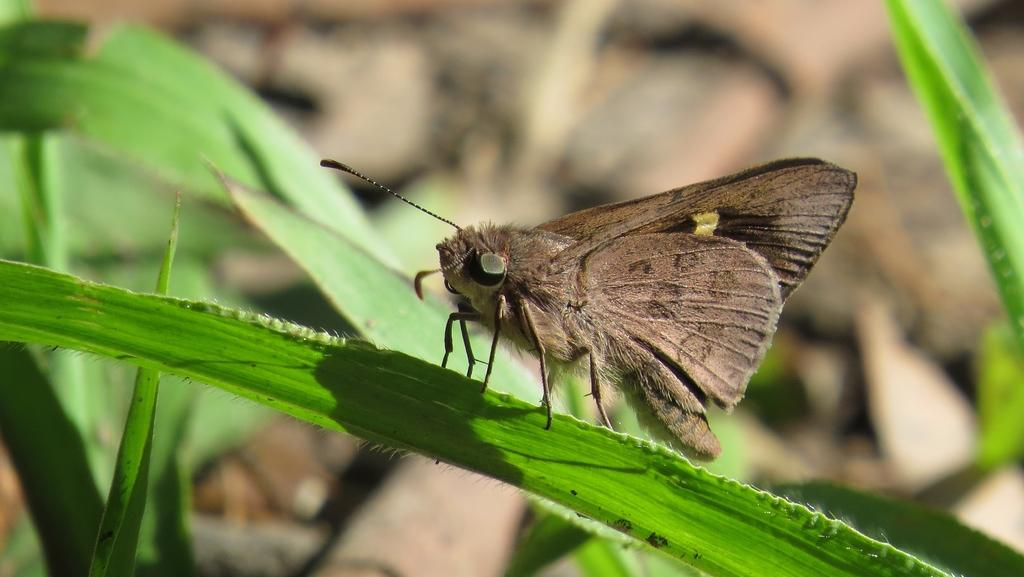What type of living organism can be seen in the image? There is an insect in the image. What other elements are present in the image besides the insect? There are plants in the image. Can you describe the background of the image? The background of the image is blurred. What type of tax is being discussed in the image? There is no discussion of tax in the image; it features an insect and plants with a blurred background. 